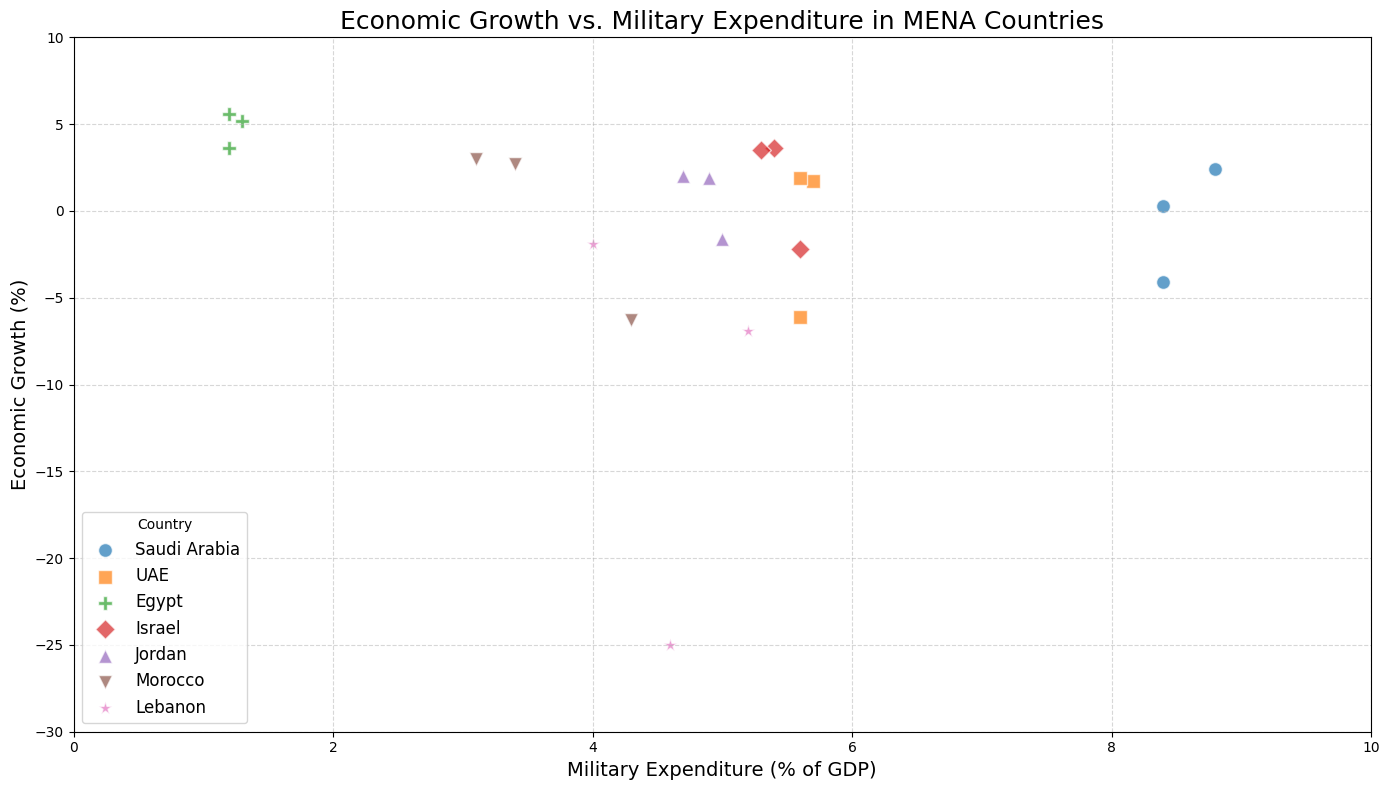Which country had the lowest economic growth in 2020? To determine the country with the lowest economic growth in 2020, observe the scatter plot and identify which data point is lowest on the Y-axis specifically for 2020.
Answer: Lebanon Which two countries show a positive economic growth in 2019 and a negative economic growth in 2020? Observe the scatter plot, and check which countries have a data point above zero for 2019 and below zero for 2020.
Answer: Israel, Jordan What is the difference in military expenditure between Israel and Jordan in 2020? Look at the X-axis values for Israel and Jordan in 2020 and find their military expenditures. Subtract Jordan's value from Israel's value to determine the difference.
Answer: 0.6 Which country has the highest average economic growth across the years? Calculate the average economic growth for each country by summing their economic growth values and dividing by the number of years recorded. Compare these averages to find the highest.
Answer: Egypt Compare the military expenditure of Saudi Arabia and UAE in 2019. Which country spends more on the military as a percentage of GDP? Find the military expenditure percentages for both Saudi Arabia and UAE in 2019 on the X-axis. Compare these values to see which is higher.
Answer: Saudi Arabia Which country has a more drastic change in economic growth from 2019 to 2020, UAE or Morocco? Calculate the difference in economic growth for UAE between 2019 and 2020 and do the same for Morocco. Compare the absolute values of these differences to determine which is more drastic.
Answer: Morocco What pattern, if any, can be observed between military expenditure and economic growth based on the scatter plot? Look for any trends or correlations between how changes in military expenditures (X-axis) relate to changes in economic growth (Y-axis). Assess if there is an upward, downward, or no specific trend.
Answer: No clear pattern Which country had the highest military expenditure as a percentage of GDP in 2018? Look at the X-axis values for 2018 and identify which country has the highest military expenditure percentage.
Answer: Saudi Arabia Does Lebanon's economic growth improve or worsen from 2019 to 2020? Find the economic growth data points for Lebanon in 2019 and 2020 and compare them to see if the value becomes more positive or more negative.
Answer: Worsen What is the economic growth rate of Egypt in 2018 compared to 2019? Look at the Y-axis values for Egypt in 2018 and 2019, then compare these to determine if the rate has increased or decreased.
Answer: Increased 